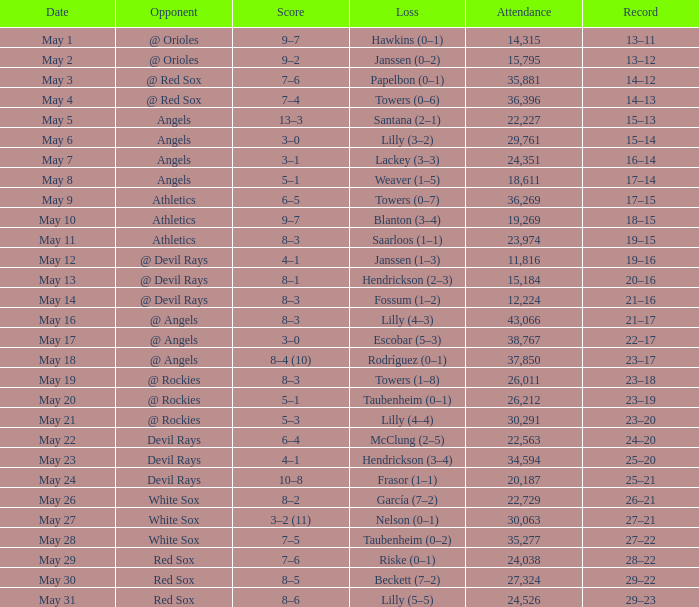Could you parse the entire table? {'header': ['Date', 'Opponent', 'Score', 'Loss', 'Attendance', 'Record'], 'rows': [['May 1', '@ Orioles', '9–7', 'Hawkins (0–1)', '14,315', '13–11'], ['May 2', '@ Orioles', '9–2', 'Janssen (0–2)', '15,795', '13–12'], ['May 3', '@ Red Sox', '7–6', 'Papelbon (0–1)', '35,881', '14–12'], ['May 4', '@ Red Sox', '7–4', 'Towers (0–6)', '36,396', '14–13'], ['May 5', 'Angels', '13–3', 'Santana (2–1)', '22,227', '15–13'], ['May 6', 'Angels', '3–0', 'Lilly (3–2)', '29,761', '15–14'], ['May 7', 'Angels', '3–1', 'Lackey (3–3)', '24,351', '16–14'], ['May 8', 'Angels', '5–1', 'Weaver (1–5)', '18,611', '17–14'], ['May 9', 'Athletics', '6–5', 'Towers (0–7)', '36,269', '17–15'], ['May 10', 'Athletics', '9–7', 'Blanton (3–4)', '19,269', '18–15'], ['May 11', 'Athletics', '8–3', 'Saarloos (1–1)', '23,974', '19–15'], ['May 12', '@ Devil Rays', '4–1', 'Janssen (1–3)', '11,816', '19–16'], ['May 13', '@ Devil Rays', '8–1', 'Hendrickson (2–3)', '15,184', '20–16'], ['May 14', '@ Devil Rays', '8–3', 'Fossum (1–2)', '12,224', '21–16'], ['May 16', '@ Angels', '8–3', 'Lilly (4–3)', '43,066', '21–17'], ['May 17', '@ Angels', '3–0', 'Escobar (5–3)', '38,767', '22–17'], ['May 18', '@ Angels', '8–4 (10)', 'Rodríguez (0–1)', '37,850', '23–17'], ['May 19', '@ Rockies', '8–3', 'Towers (1–8)', '26,011', '23–18'], ['May 20', '@ Rockies', '5–1', 'Taubenheim (0–1)', '26,212', '23–19'], ['May 21', '@ Rockies', '5–3', 'Lilly (4–4)', '30,291', '23–20'], ['May 22', 'Devil Rays', '6–4', 'McClung (2–5)', '22,563', '24–20'], ['May 23', 'Devil Rays', '4–1', 'Hendrickson (3–4)', '34,594', '25–20'], ['May 24', 'Devil Rays', '10–8', 'Frasor (1–1)', '20,187', '25–21'], ['May 26', 'White Sox', '8–2', 'García (7–2)', '22,729', '26–21'], ['May 27', 'White Sox', '3–2 (11)', 'Nelson (0–1)', '30,063', '27–21'], ['May 28', 'White Sox', '7–5', 'Taubenheim (0–2)', '35,277', '27–22'], ['May 29', 'Red Sox', '7–6', 'Riske (0–1)', '24,038', '28–22'], ['May 30', 'Red Sox', '8–5', 'Beckett (7–2)', '27,324', '29–22'], ['May 31', 'Red Sox', '8–6', 'Lilly (5–5)', '24,526', '29–23']]} What was the typical attendance for games with a loss of papelbon (0–1)? 35881.0. 